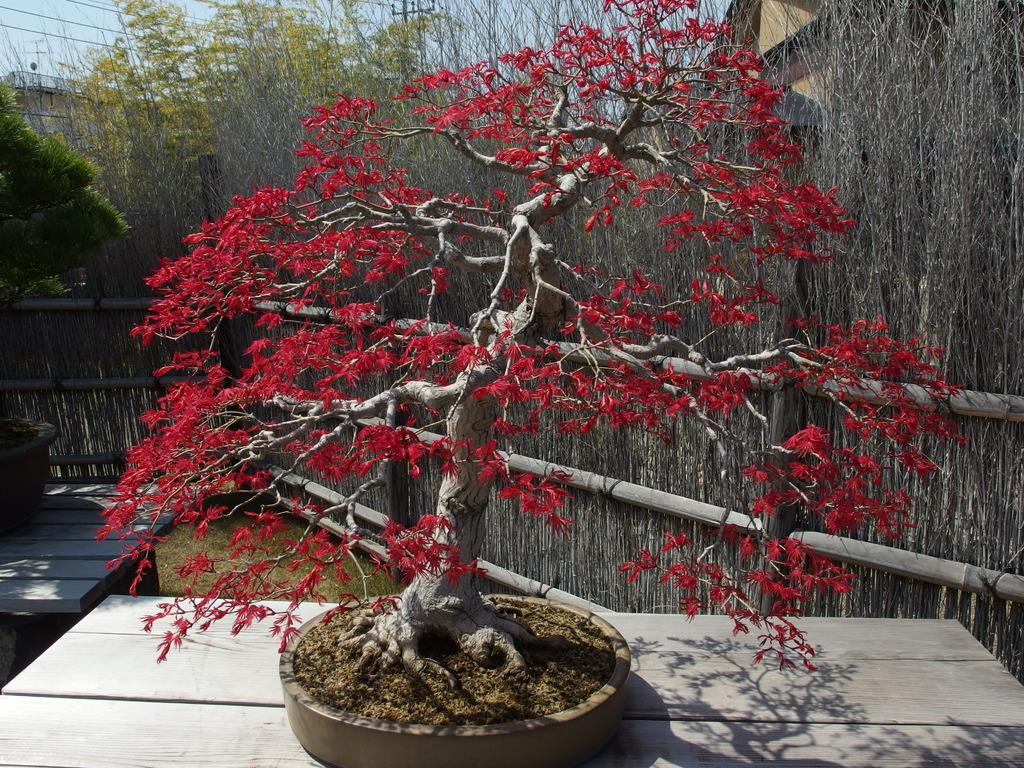What is placed on the wooden table in the image? There is a tree on a wooden table in the image. Can you describe the colors of the tree? The tree has red and ash colors. What can be seen in the background of the image? There is wooden railing, buildings, trees, wires, and the sky visible in the background of the image. How many chairs are placed around the tree in the image? There are no chairs present in the image; it only features a tree on a wooden table. What type of crayon can be seen being used to draw on the tree in the image? There is no crayon or drawing activity present in the image; it only features a tree with red and ash colors. 